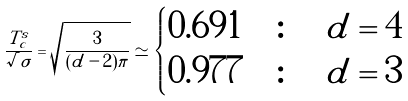Convert formula to latex. <formula><loc_0><loc_0><loc_500><loc_500>\frac { T ^ { s } _ { c } } { \surd \sigma } = \sqrt { \frac { 3 } { ( d - 2 ) \pi } } \simeq \begin{cases} 0 . 6 9 1 & \colon \quad d = 4 \\ 0 . 9 7 7 & \colon \quad d = 3 \end{cases}</formula> 